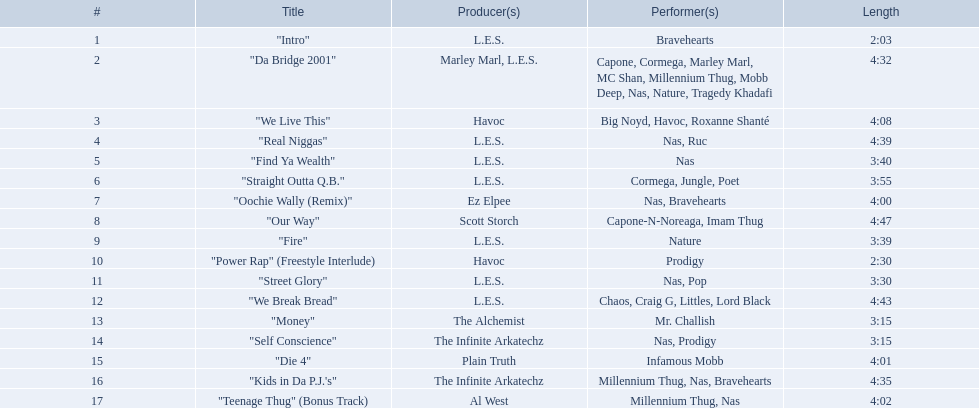What are all the tunes on the album? "Intro", "Da Bridge 2001", "We Live This", "Real Niggas", "Find Ya Wealth", "Straight Outta Q.B.", "Oochie Wally (Remix)", "Our Way", "Fire", "Power Rap" (Freestyle Interlude), "Street Glory", "We Break Bread", "Money", "Self Conscience", "Die 4", "Kids in Da P.J.'s", "Teenage Thug" (Bonus Track). Which one has the smallest duration? "Intro". What is the length of that tune? 2:03. 